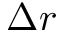<formula> <loc_0><loc_0><loc_500><loc_500>\Delta r</formula> 